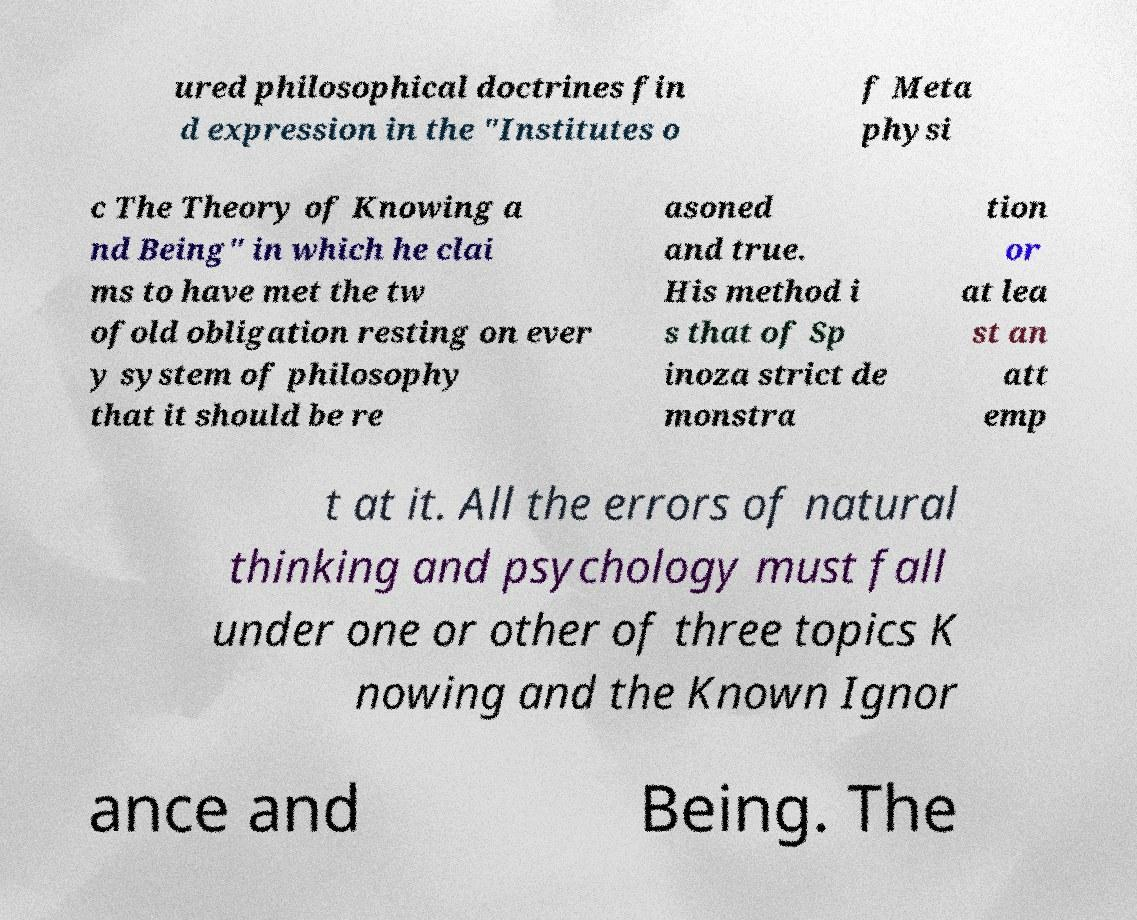I need the written content from this picture converted into text. Can you do that? ured philosophical doctrines fin d expression in the "Institutes o f Meta physi c The Theory of Knowing a nd Being" in which he clai ms to have met the tw ofold obligation resting on ever y system of philosophy that it should be re asoned and true. His method i s that of Sp inoza strict de monstra tion or at lea st an att emp t at it. All the errors of natural thinking and psychology must fall under one or other of three topics K nowing and the Known Ignor ance and Being. The 